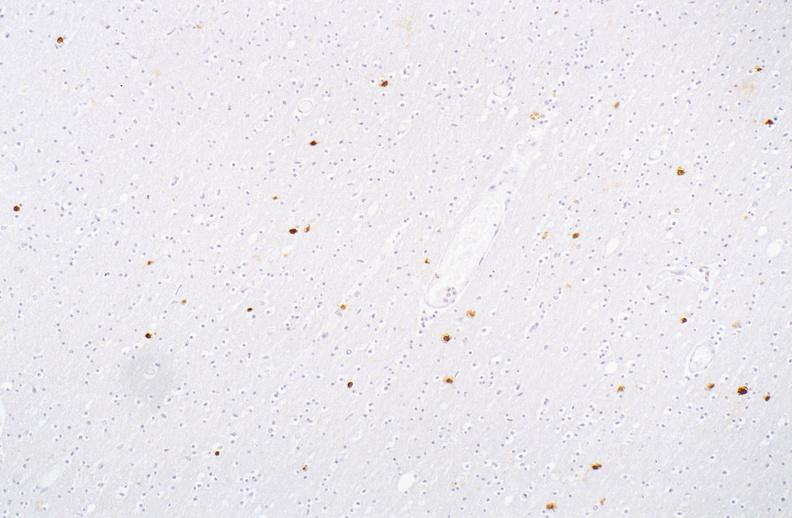what does this image show?
Answer the question using a single word or phrase. Herpes simplex virus 